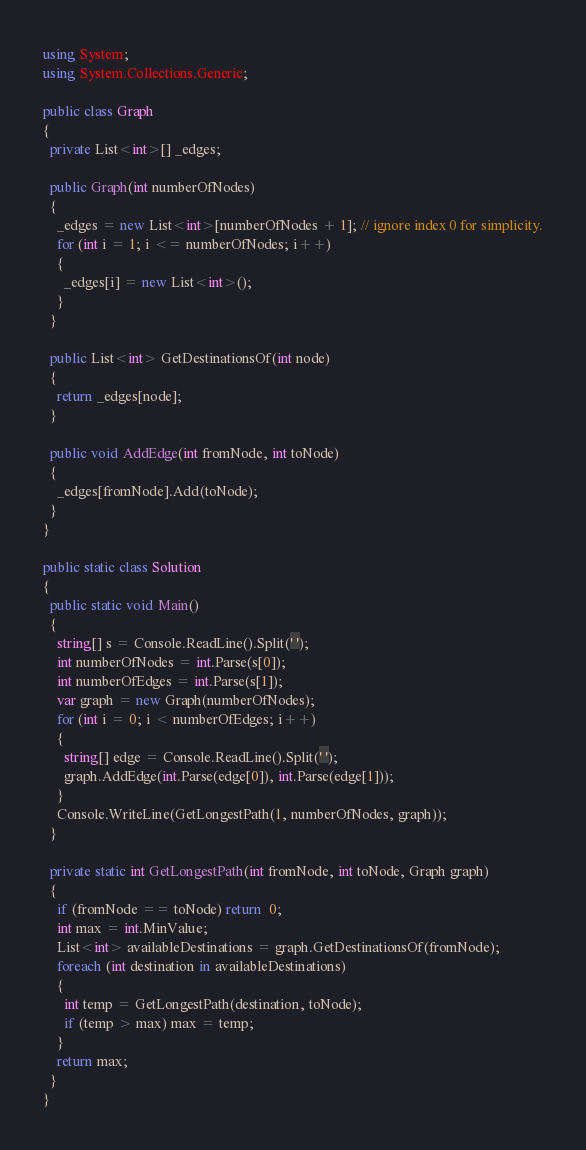Convert code to text. <code><loc_0><loc_0><loc_500><loc_500><_C#_>using System;
using System.Collections.Generic;

public class Graph
{
  private List<int>[] _edges;

  public Graph(int numberOfNodes)
  {
    _edges = new List<int>[numberOfNodes + 1]; // ignore index 0 for simplicity.
    for (int i = 1; i <= numberOfNodes; i++)
    {
      _edges[i] = new List<int>();
    }
  }

  public List<int> GetDestinationsOf(int node)
  {
    return _edges[node];
  }

  public void AddEdge(int fromNode, int toNode)
  {
    _edges[fromNode].Add(toNode);
  }
}

public static class Solution
{
  public static void Main()
  {
    string[] s = Console.ReadLine().Split(' ');
    int numberOfNodes = int.Parse(s[0]);
    int numberOfEdges = int.Parse(s[1]);
    var graph = new Graph(numberOfNodes);
    for (int i = 0; i < numberOfEdges; i++)
    {
      string[] edge = Console.ReadLine().Split(' ');
      graph.AddEdge(int.Parse(edge[0]), int.Parse(edge[1]));
    }
    Console.WriteLine(GetLongestPath(1, numberOfNodes, graph));
  }

  private static int GetLongestPath(int fromNode, int toNode, Graph graph)
  {
    if (fromNode == toNode) return  0;
    int max = int.MinValue;
    List<int> availableDestinations = graph.GetDestinationsOf(fromNode);
    foreach (int destination in availableDestinations)
    {
      int temp = GetLongestPath(destination, toNode);
      if (temp > max) max = temp;
    }
    return max;
  }
}</code> 